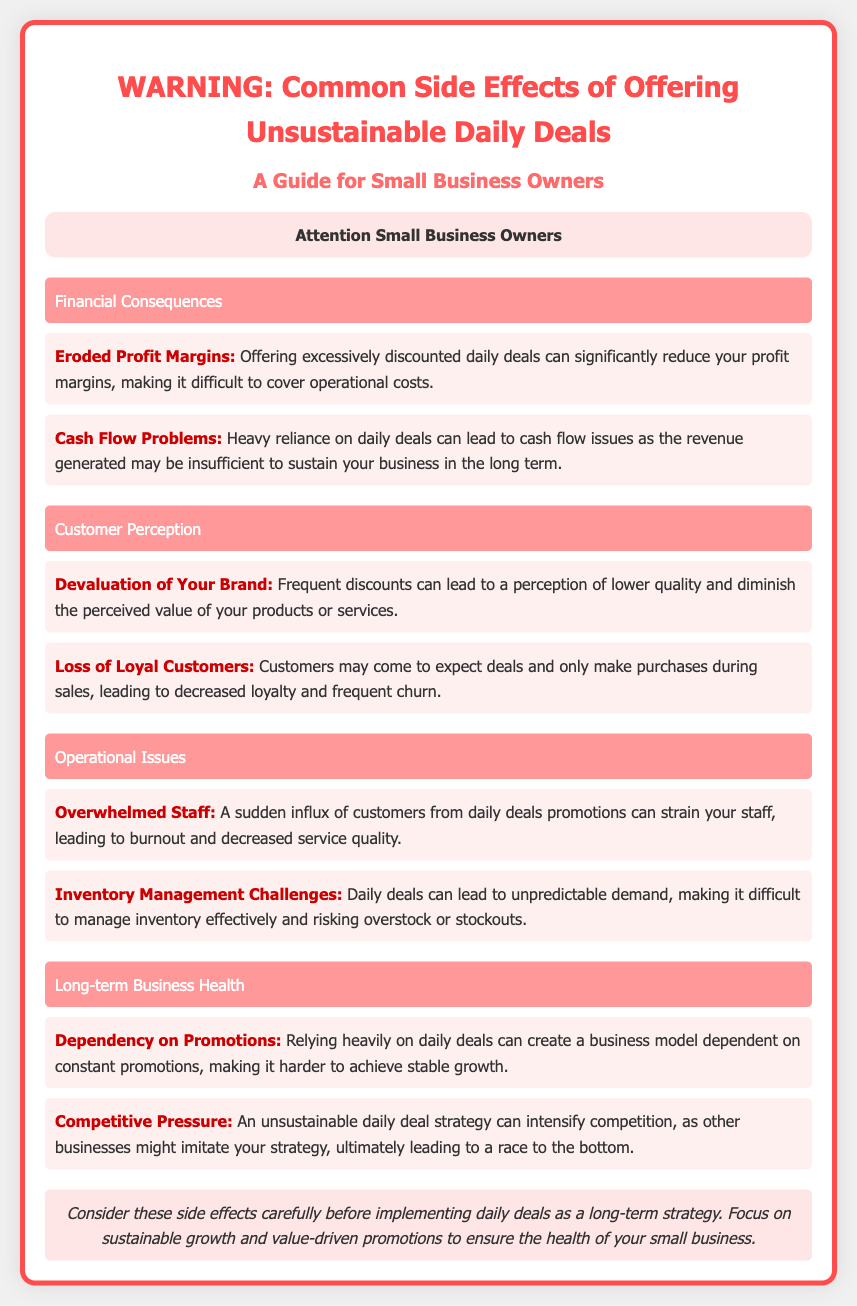what is one of the financial consequences of offering unsustainable daily deals? The document lists financial consequences, including "Eroded Profit Margins" as a specific issue resulting from excessive discounts.
Answer: Eroded Profit Margins what can heavy reliance on daily deals lead to? The document states that it can lead to "cash flow problems" as the revenue generated may be insufficient for long-term sustainability.
Answer: Cash Flow Problems what phrase describes the perception created by frequent discounts? The document mentions that it can lead to "Devaluation of Your Brand," which impacts customers' perception of product quality.
Answer: Devaluation of Your Brand what is a potential operational issue mentioned? The document highlights "Inventory Management Challenges" as a difficulty stemming from daily deals resulting in unpredictable demand.
Answer: Inventory Management Challenges what is the risk of dependency on daily deals? The document outlines that it creates a "Dependency on Promotions," which can hinder stable growth.
Answer: Dependency on Promotions how does daily deals affect customer loyalty? According to the document, reliance on discounts can cause a "Loss of Loyal Customers," as buying behavior shifts to only making purchases during sales.
Answer: Loss of Loyal Customers what long-term effect can arise from competitive pressure? The document notes that competitive pressure can lead to a "race to the bottom," as businesses may copy unsustainable promotional strategies.
Answer: Race to the bottom what should small business owners consider before implementing daily deals? The footer suggests to focus on "sustainable growth and value-driven promotions" to mitigate the negative effects of daily deals.
Answer: Sustainable growth and value-driven promotions 